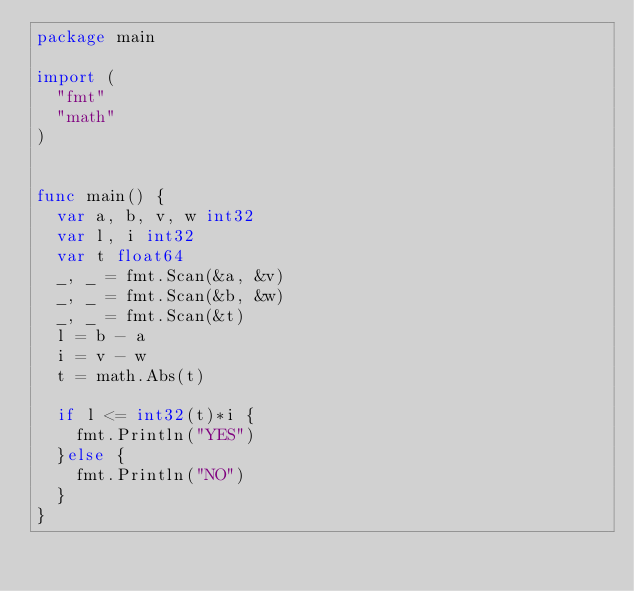<code> <loc_0><loc_0><loc_500><loc_500><_Go_>package main

import (
	"fmt"
	"math"
)


func main() {
	var a, b, v, w int32
	var l, i int32
	var t float64
	_, _ = fmt.Scan(&a, &v)
	_, _ = fmt.Scan(&b, &w)
	_, _ = fmt.Scan(&t)
	l = b - a
	i = v - w
	t = math.Abs(t)

	if l <= int32(t)*i {
		fmt.Println("YES")
	}else {
		fmt.Println("NO")
	}
}</code> 